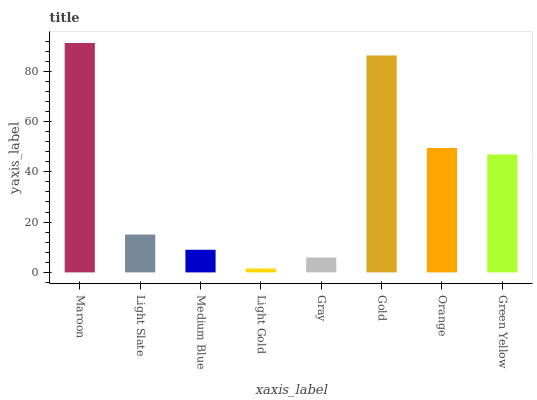Is Light Slate the minimum?
Answer yes or no. No. Is Light Slate the maximum?
Answer yes or no. No. Is Maroon greater than Light Slate?
Answer yes or no. Yes. Is Light Slate less than Maroon?
Answer yes or no. Yes. Is Light Slate greater than Maroon?
Answer yes or no. No. Is Maroon less than Light Slate?
Answer yes or no. No. Is Green Yellow the high median?
Answer yes or no. Yes. Is Light Slate the low median?
Answer yes or no. Yes. Is Light Slate the high median?
Answer yes or no. No. Is Orange the low median?
Answer yes or no. No. 